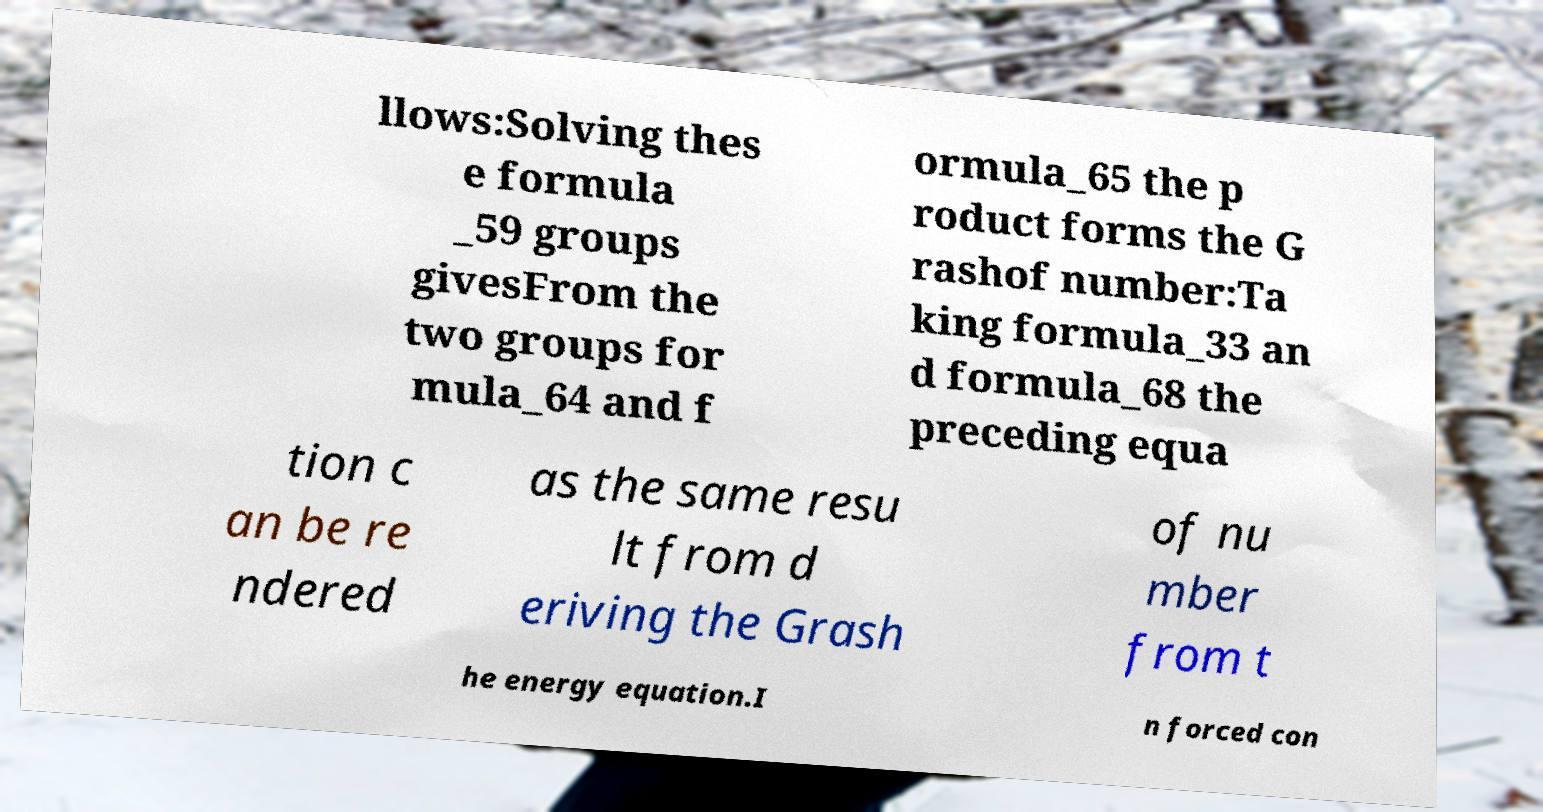Could you extract and type out the text from this image? llows:Solving thes e formula _59 groups givesFrom the two groups for mula_64 and f ormula_65 the p roduct forms the G rashof number:Ta king formula_33 an d formula_68 the preceding equa tion c an be re ndered as the same resu lt from d eriving the Grash of nu mber from t he energy equation.I n forced con 